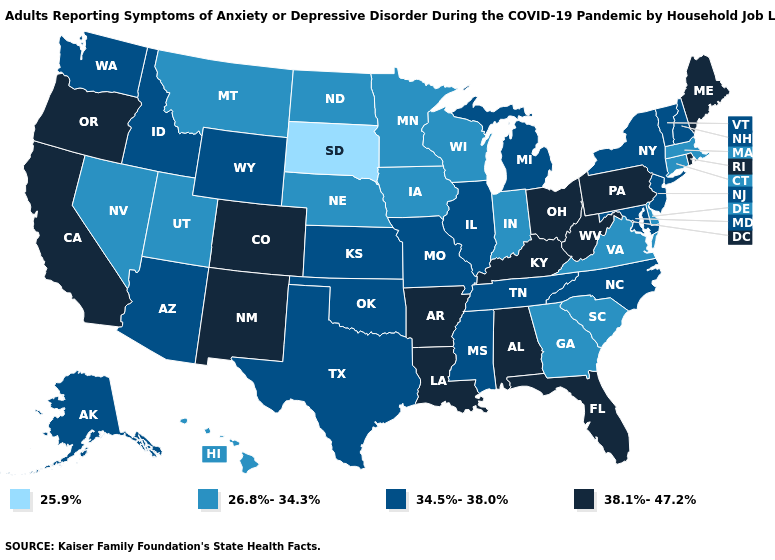What is the value of New Jersey?
Answer briefly. 34.5%-38.0%. What is the value of New Hampshire?
Write a very short answer. 34.5%-38.0%. What is the lowest value in states that border Georgia?
Concise answer only. 26.8%-34.3%. Does Virginia have the same value as Hawaii?
Concise answer only. Yes. Among the states that border Wyoming , which have the lowest value?
Short answer required. South Dakota. Among the states that border Vermont , does Massachusetts have the lowest value?
Give a very brief answer. Yes. What is the value of Louisiana?
Concise answer only. 38.1%-47.2%. Name the states that have a value in the range 38.1%-47.2%?
Give a very brief answer. Alabama, Arkansas, California, Colorado, Florida, Kentucky, Louisiana, Maine, New Mexico, Ohio, Oregon, Pennsylvania, Rhode Island, West Virginia. Does Arizona have the highest value in the West?
Concise answer only. No. What is the highest value in the South ?
Write a very short answer. 38.1%-47.2%. Is the legend a continuous bar?
Concise answer only. No. Name the states that have a value in the range 38.1%-47.2%?
Quick response, please. Alabama, Arkansas, California, Colorado, Florida, Kentucky, Louisiana, Maine, New Mexico, Ohio, Oregon, Pennsylvania, Rhode Island, West Virginia. Does Nevada have the lowest value in the West?
Quick response, please. Yes. Does the first symbol in the legend represent the smallest category?
Answer briefly. Yes. Which states have the lowest value in the USA?
Quick response, please. South Dakota. 